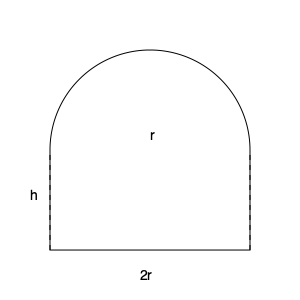In our monastery's new church, we are designing a hemispherical dome with a radius of 10 meters. To calculate the volume of air inside the dome for proper ventilation, we need to use calculus. If we slice the dome horizontally at a height $h$ from the base, the radius of the circular cross-section is given by $r(h) = \sqrt{20h - h^2}$. Calculate the volume of the dome using the method of cylindrical shells. To solve this problem, we'll use the method of cylindrical shells and follow these steps:

1) The volume of a cylindrical shell is given by $dV = 2\pi r h dh$, where $r$ is the radius of the shell and $h$ is its height.

2) We're given that $r(h) = \sqrt{20h - h^2}$. We need to integrate this from $h = 0$ to $h = 10$ (the height of the dome).

3) Set up the integral:

   $$V = \int_0^{10} 2\pi r(h) h dh = \int_0^{10} 2\pi h\sqrt{20h - h^2} dh$$

4) This integral is challenging to solve directly. Let's use the substitution $u = 10 - h$:
   
   $h = 10 - u$
   $dh = -du$
   When $h = 0$, $u = 10$
   When $h = 10$, $u = 0$

5) Rewrite the integral:

   $$V = \int_{10}^0 2\pi (10-u)\sqrt{20(10-u) - (10-u)^2} (-du)$$
   $$= \int_0^{10} 2\pi (10-u)\sqrt{100 - u^2} du$$

6) This is now in the form $\int \sqrt{a^2 - u^2} du$, which has a known solution.

7) The solution is:

   $$V = 2\pi \left[ 10\left(\frac{u}{2}\sqrt{100-u^2} + 50\arcsin\frac{u}{10}\right) - \frac{1}{3}(100-u^2)^{3/2} \right]_0^{10}$$

8) Evaluating at the limits:

   $$V = 2\pi \left[ 10\left(0 + 50\cdot\frac{\pi}{2}\right) - 0 \right] - 2\pi \left[ 10\left(0 + 0\right) - \frac{1000}{3} \right]$$

9) Simplify:

   $$V = 2\pi \left( 500\cdot\frac{\pi}{2} + \frac{1000}{3} \right) = 500\pi^2 + \frac{2000\pi}{3}$$

10) This can be further simplified to:

    $$V = \frac{1000\pi}{3}(1.5\pi + 1) \approx 2094.4 \text{ cubic meters}$$
Answer: $\frac{1000\pi}{3}(1.5\pi + 1)$ cubic meters 